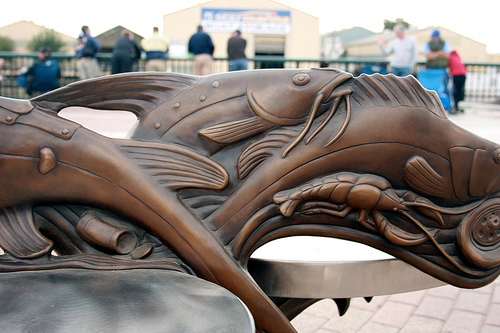<image>
Is there a statue next to the man? No. The statue is not positioned next to the man. They are located in different areas of the scene. 